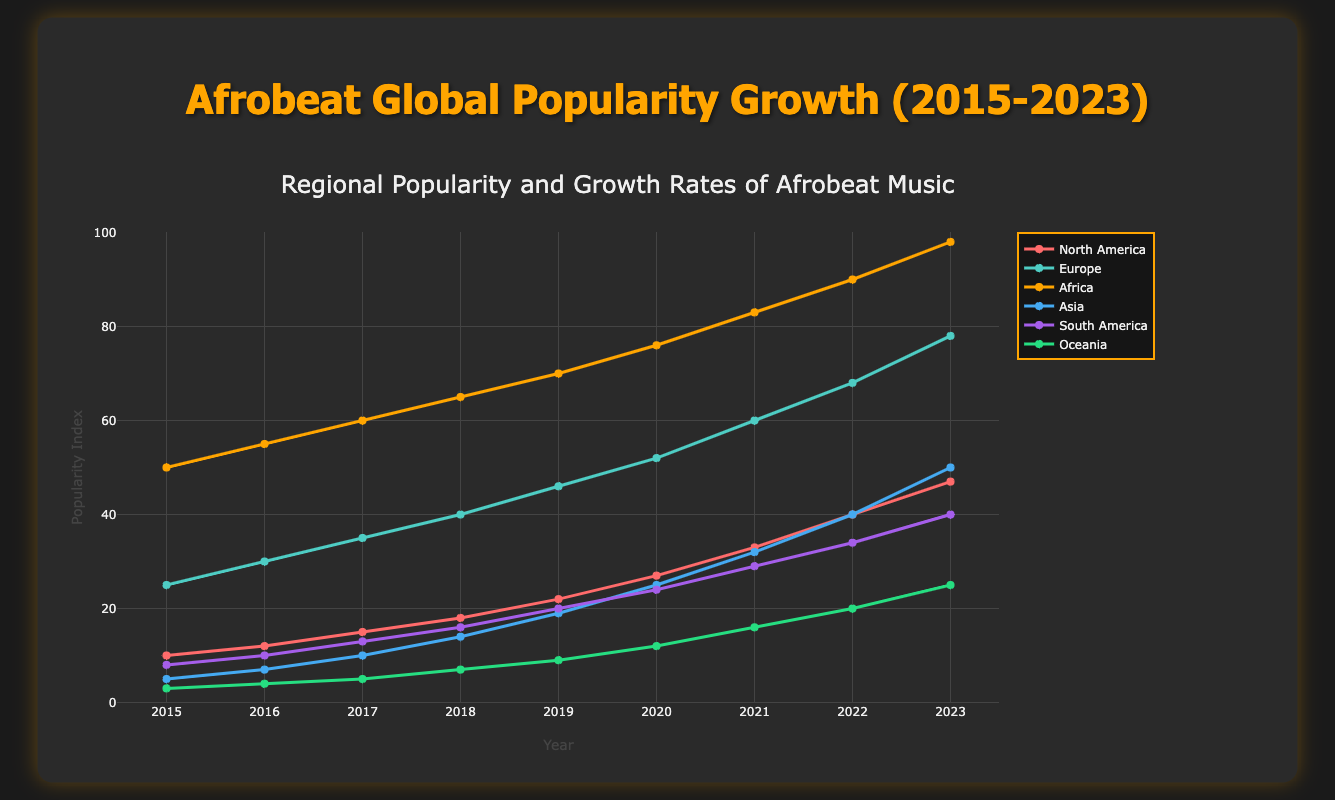What's the title of the figure? The title is always displayed prominently at the top of the plot. Here, it reads "Afrobeat Global Popularity Growth (2015-2023)".
Answer: Afrobeat Global Popularity Growth (2015-2023) What are the x-axis and y-axis titles? The x-axis title is positioned along the horizontal axis and it reads "Year". The y-axis title is along the vertical axis and it reads "Popularity Index".
Answer: Year, Popularity Index How many regions are depicted in the scatter plot? Each region is shown in a different color and listed in the legend. Here, six regions are represented.
Answer: Six Which region had the highest popularity index in 2023? By comparing the popularity indices for the year 2023 among all regions, Africa shows the highest index at 98.
Answer: Africa What was the popularity index for Asia in 2015 and how much did it grow by 2023? The data points for Asia in 2015 and 2023 show a popularity index of 5 in 2015 and 50 in 2023. The growth can be found by subtracting 5 from 50.
Answer: 5, 45 Which two regions exhibited the most noticeable popularity growth between 2015 and 2023? Look at the start and end popularity indices. North America (10 to 47) and Asia (5 to 50) show significant growth. Compare these figures to other regions for final confirmation.
Answer: North America, Asia Did Europe experience a steady increase in popularity index every year from 2015 to 2023? Check the data points for Europe from 2015 to 2023. The values show a consistent increase each year.
Answer: Yes What's the difference in popularity index between South America and Oceania in 2020? Find the indices for both regions in 2020 and subtract the popularity index of Oceania (12) from South America (24).
Answer: 12 Which region had the smallest popularity index in 2018 and what was its value? By comparing the 2018 data points for all regions, Oceania has the smallest index with a value of 7.
Answer: Oceania, 7 Comparing the trend lines, which region appears to have the most linear growth rate? By observing the plot, Africa's trend line appears the most linear, indicating a consistent yearly increase.
Answer: Africa 